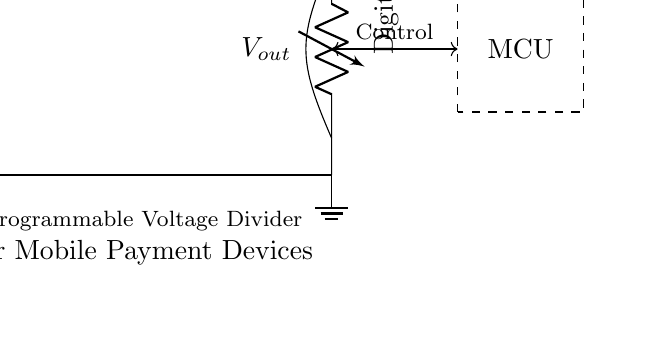What is the input voltage of this circuit? The input voltage is denoted as V sub in, which is specified at the power supply located at the top left of the circuit diagram.
Answer: V sub in How many resistors are in the circuit? There are three resistors illustrated in the circuit diagram, labeled as R sub 1, R sub 2, and R sub 3, connected in series.
Answer: Three What component is used for voltage adjustment? The component used for voltage adjustment is labeled as Digital Pot, indicating it is a digital potentiometer which allows for programmable resistance and hence voltage division.
Answer: Digital Pot What type of device is shown controlling the voltage divider? The device is labeled as MCU, which stands for Microcontroller Unit, indicating that it controls the operation of the voltage divider.
Answer: Microcontroller Unit What is the output voltage in relation to the digital potentiometer? The output voltage, labeled as V sub out, is derived from the junction between the resistors and the digital potentiometer, reflecting the divided voltage based on the settings of R sub 1, R sub 2, and the Digital Pot.
Answer: V sub out Why is a programmable voltage divider used in mobile payment devices? A programmable voltage divider is used to dynamically adjust the output voltage based on varying power requirements of different components in mobile payment devices, promoting efficient power management.
Answer: Dynamic power management 